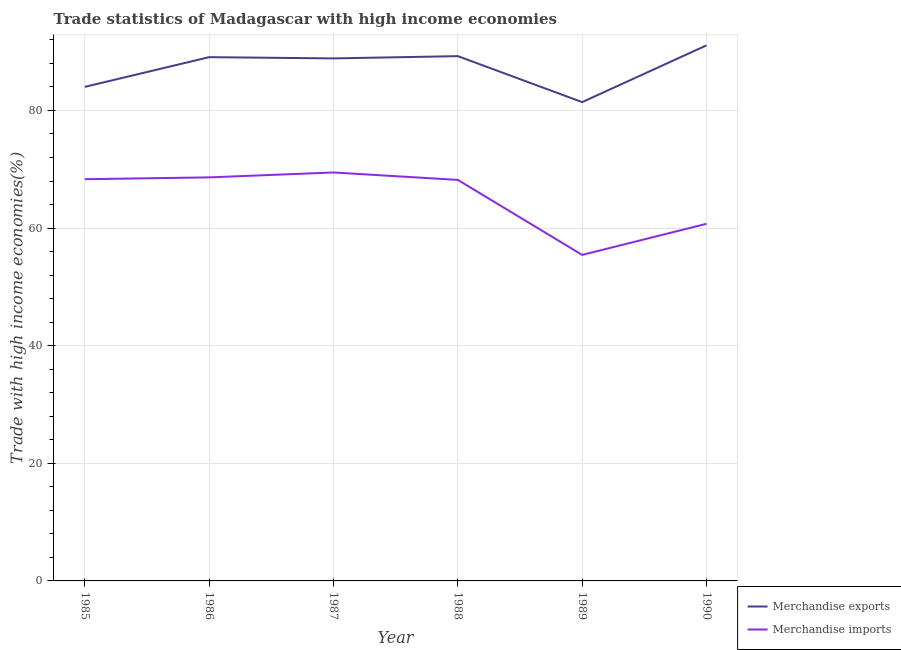Does the line corresponding to merchandise imports intersect with the line corresponding to merchandise exports?
Your answer should be very brief. No. Is the number of lines equal to the number of legend labels?
Your answer should be very brief. Yes. What is the merchandise exports in 1985?
Your response must be concise. 84.01. Across all years, what is the maximum merchandise imports?
Give a very brief answer. 69.45. Across all years, what is the minimum merchandise imports?
Your answer should be very brief. 55.44. In which year was the merchandise imports maximum?
Provide a short and direct response. 1987. In which year was the merchandise exports minimum?
Offer a terse response. 1989. What is the total merchandise imports in the graph?
Make the answer very short. 390.74. What is the difference between the merchandise exports in 1986 and that in 1988?
Offer a terse response. -0.17. What is the difference between the merchandise exports in 1986 and the merchandise imports in 1987?
Give a very brief answer. 19.61. What is the average merchandise exports per year?
Offer a terse response. 87.27. In the year 1989, what is the difference between the merchandise imports and merchandise exports?
Ensure brevity in your answer.  -25.98. In how many years, is the merchandise imports greater than 56 %?
Your answer should be very brief. 5. What is the ratio of the merchandise imports in 1985 to that in 1986?
Your answer should be compact. 1. Is the merchandise exports in 1986 less than that in 1990?
Give a very brief answer. Yes. What is the difference between the highest and the second highest merchandise exports?
Make the answer very short. 1.83. What is the difference between the highest and the lowest merchandise exports?
Keep it short and to the point. 9.65. In how many years, is the merchandise exports greater than the average merchandise exports taken over all years?
Ensure brevity in your answer.  4. Is the sum of the merchandise imports in 1985 and 1986 greater than the maximum merchandise exports across all years?
Offer a very short reply. Yes. Does the merchandise imports monotonically increase over the years?
Your answer should be very brief. No. Is the merchandise exports strictly less than the merchandise imports over the years?
Your answer should be compact. No. How many lines are there?
Ensure brevity in your answer.  2. How are the legend labels stacked?
Make the answer very short. Vertical. What is the title of the graph?
Offer a terse response. Trade statistics of Madagascar with high income economies. Does "RDB nonconcessional" appear as one of the legend labels in the graph?
Your response must be concise. No. What is the label or title of the Y-axis?
Make the answer very short. Trade with high income economies(%). What is the Trade with high income economies(%) of Merchandise exports in 1985?
Your answer should be compact. 84.01. What is the Trade with high income economies(%) in Merchandise imports in 1985?
Offer a very short reply. 68.31. What is the Trade with high income economies(%) in Merchandise exports in 1986?
Ensure brevity in your answer.  89.06. What is the Trade with high income economies(%) of Merchandise imports in 1986?
Your answer should be very brief. 68.62. What is the Trade with high income economies(%) of Merchandise exports in 1987?
Your answer should be very brief. 88.85. What is the Trade with high income economies(%) of Merchandise imports in 1987?
Ensure brevity in your answer.  69.45. What is the Trade with high income economies(%) of Merchandise exports in 1988?
Offer a very short reply. 89.24. What is the Trade with high income economies(%) in Merchandise imports in 1988?
Your answer should be very brief. 68.19. What is the Trade with high income economies(%) of Merchandise exports in 1989?
Offer a terse response. 81.42. What is the Trade with high income economies(%) of Merchandise imports in 1989?
Offer a very short reply. 55.44. What is the Trade with high income economies(%) in Merchandise exports in 1990?
Your answer should be very brief. 91.07. What is the Trade with high income economies(%) in Merchandise imports in 1990?
Provide a succinct answer. 60.73. Across all years, what is the maximum Trade with high income economies(%) in Merchandise exports?
Ensure brevity in your answer.  91.07. Across all years, what is the maximum Trade with high income economies(%) in Merchandise imports?
Give a very brief answer. 69.45. Across all years, what is the minimum Trade with high income economies(%) of Merchandise exports?
Offer a very short reply. 81.42. Across all years, what is the minimum Trade with high income economies(%) of Merchandise imports?
Your answer should be very brief. 55.44. What is the total Trade with high income economies(%) of Merchandise exports in the graph?
Make the answer very short. 523.65. What is the total Trade with high income economies(%) of Merchandise imports in the graph?
Give a very brief answer. 390.74. What is the difference between the Trade with high income economies(%) in Merchandise exports in 1985 and that in 1986?
Make the answer very short. -5.05. What is the difference between the Trade with high income economies(%) in Merchandise imports in 1985 and that in 1986?
Offer a terse response. -0.31. What is the difference between the Trade with high income economies(%) of Merchandise exports in 1985 and that in 1987?
Provide a short and direct response. -4.84. What is the difference between the Trade with high income economies(%) in Merchandise imports in 1985 and that in 1987?
Offer a terse response. -1.14. What is the difference between the Trade with high income economies(%) of Merchandise exports in 1985 and that in 1988?
Offer a very short reply. -5.22. What is the difference between the Trade with high income economies(%) of Merchandise imports in 1985 and that in 1988?
Provide a succinct answer. 0.12. What is the difference between the Trade with high income economies(%) in Merchandise exports in 1985 and that in 1989?
Your answer should be compact. 2.59. What is the difference between the Trade with high income economies(%) of Merchandise imports in 1985 and that in 1989?
Offer a very short reply. 12.87. What is the difference between the Trade with high income economies(%) of Merchandise exports in 1985 and that in 1990?
Make the answer very short. -7.06. What is the difference between the Trade with high income economies(%) of Merchandise imports in 1985 and that in 1990?
Your answer should be very brief. 7.58. What is the difference between the Trade with high income economies(%) of Merchandise exports in 1986 and that in 1987?
Make the answer very short. 0.21. What is the difference between the Trade with high income economies(%) in Merchandise imports in 1986 and that in 1987?
Offer a terse response. -0.83. What is the difference between the Trade with high income economies(%) in Merchandise exports in 1986 and that in 1988?
Provide a short and direct response. -0.17. What is the difference between the Trade with high income economies(%) of Merchandise imports in 1986 and that in 1988?
Your answer should be compact. 0.43. What is the difference between the Trade with high income economies(%) of Merchandise exports in 1986 and that in 1989?
Offer a terse response. 7.64. What is the difference between the Trade with high income economies(%) of Merchandise imports in 1986 and that in 1989?
Offer a terse response. 13.18. What is the difference between the Trade with high income economies(%) of Merchandise exports in 1986 and that in 1990?
Your answer should be compact. -2.01. What is the difference between the Trade with high income economies(%) of Merchandise imports in 1986 and that in 1990?
Provide a short and direct response. 7.89. What is the difference between the Trade with high income economies(%) of Merchandise exports in 1987 and that in 1988?
Your response must be concise. -0.38. What is the difference between the Trade with high income economies(%) in Merchandise imports in 1987 and that in 1988?
Keep it short and to the point. 1.26. What is the difference between the Trade with high income economies(%) in Merchandise exports in 1987 and that in 1989?
Give a very brief answer. 7.43. What is the difference between the Trade with high income economies(%) in Merchandise imports in 1987 and that in 1989?
Ensure brevity in your answer.  14.02. What is the difference between the Trade with high income economies(%) in Merchandise exports in 1987 and that in 1990?
Offer a very short reply. -2.22. What is the difference between the Trade with high income economies(%) of Merchandise imports in 1987 and that in 1990?
Provide a short and direct response. 8.73. What is the difference between the Trade with high income economies(%) in Merchandise exports in 1988 and that in 1989?
Your answer should be very brief. 7.82. What is the difference between the Trade with high income economies(%) of Merchandise imports in 1988 and that in 1989?
Your answer should be very brief. 12.75. What is the difference between the Trade with high income economies(%) in Merchandise exports in 1988 and that in 1990?
Offer a very short reply. -1.83. What is the difference between the Trade with high income economies(%) of Merchandise imports in 1988 and that in 1990?
Your answer should be compact. 7.46. What is the difference between the Trade with high income economies(%) in Merchandise exports in 1989 and that in 1990?
Give a very brief answer. -9.65. What is the difference between the Trade with high income economies(%) in Merchandise imports in 1989 and that in 1990?
Offer a very short reply. -5.29. What is the difference between the Trade with high income economies(%) in Merchandise exports in 1985 and the Trade with high income economies(%) in Merchandise imports in 1986?
Your answer should be compact. 15.39. What is the difference between the Trade with high income economies(%) of Merchandise exports in 1985 and the Trade with high income economies(%) of Merchandise imports in 1987?
Ensure brevity in your answer.  14.56. What is the difference between the Trade with high income economies(%) in Merchandise exports in 1985 and the Trade with high income economies(%) in Merchandise imports in 1988?
Keep it short and to the point. 15.82. What is the difference between the Trade with high income economies(%) in Merchandise exports in 1985 and the Trade with high income economies(%) in Merchandise imports in 1989?
Offer a very short reply. 28.58. What is the difference between the Trade with high income economies(%) in Merchandise exports in 1985 and the Trade with high income economies(%) in Merchandise imports in 1990?
Keep it short and to the point. 23.28. What is the difference between the Trade with high income economies(%) in Merchandise exports in 1986 and the Trade with high income economies(%) in Merchandise imports in 1987?
Your answer should be very brief. 19.61. What is the difference between the Trade with high income economies(%) of Merchandise exports in 1986 and the Trade with high income economies(%) of Merchandise imports in 1988?
Keep it short and to the point. 20.87. What is the difference between the Trade with high income economies(%) in Merchandise exports in 1986 and the Trade with high income economies(%) in Merchandise imports in 1989?
Offer a very short reply. 33.63. What is the difference between the Trade with high income economies(%) in Merchandise exports in 1986 and the Trade with high income economies(%) in Merchandise imports in 1990?
Keep it short and to the point. 28.33. What is the difference between the Trade with high income economies(%) of Merchandise exports in 1987 and the Trade with high income economies(%) of Merchandise imports in 1988?
Your answer should be very brief. 20.66. What is the difference between the Trade with high income economies(%) of Merchandise exports in 1987 and the Trade with high income economies(%) of Merchandise imports in 1989?
Offer a terse response. 33.42. What is the difference between the Trade with high income economies(%) in Merchandise exports in 1987 and the Trade with high income economies(%) in Merchandise imports in 1990?
Ensure brevity in your answer.  28.12. What is the difference between the Trade with high income economies(%) in Merchandise exports in 1988 and the Trade with high income economies(%) in Merchandise imports in 1989?
Ensure brevity in your answer.  33.8. What is the difference between the Trade with high income economies(%) in Merchandise exports in 1988 and the Trade with high income economies(%) in Merchandise imports in 1990?
Your answer should be compact. 28.51. What is the difference between the Trade with high income economies(%) of Merchandise exports in 1989 and the Trade with high income economies(%) of Merchandise imports in 1990?
Your answer should be very brief. 20.69. What is the average Trade with high income economies(%) of Merchandise exports per year?
Offer a terse response. 87.27. What is the average Trade with high income economies(%) of Merchandise imports per year?
Your answer should be compact. 65.12. In the year 1985, what is the difference between the Trade with high income economies(%) in Merchandise exports and Trade with high income economies(%) in Merchandise imports?
Offer a very short reply. 15.7. In the year 1986, what is the difference between the Trade with high income economies(%) of Merchandise exports and Trade with high income economies(%) of Merchandise imports?
Provide a succinct answer. 20.44. In the year 1987, what is the difference between the Trade with high income economies(%) of Merchandise exports and Trade with high income economies(%) of Merchandise imports?
Offer a very short reply. 19.4. In the year 1988, what is the difference between the Trade with high income economies(%) of Merchandise exports and Trade with high income economies(%) of Merchandise imports?
Provide a succinct answer. 21.05. In the year 1989, what is the difference between the Trade with high income economies(%) of Merchandise exports and Trade with high income economies(%) of Merchandise imports?
Offer a very short reply. 25.98. In the year 1990, what is the difference between the Trade with high income economies(%) in Merchandise exports and Trade with high income economies(%) in Merchandise imports?
Make the answer very short. 30.34. What is the ratio of the Trade with high income economies(%) in Merchandise exports in 1985 to that in 1986?
Provide a succinct answer. 0.94. What is the ratio of the Trade with high income economies(%) of Merchandise imports in 1985 to that in 1986?
Make the answer very short. 1. What is the ratio of the Trade with high income economies(%) of Merchandise exports in 1985 to that in 1987?
Ensure brevity in your answer.  0.95. What is the ratio of the Trade with high income economies(%) of Merchandise imports in 1985 to that in 1987?
Keep it short and to the point. 0.98. What is the ratio of the Trade with high income economies(%) in Merchandise exports in 1985 to that in 1988?
Provide a succinct answer. 0.94. What is the ratio of the Trade with high income economies(%) of Merchandise imports in 1985 to that in 1988?
Your answer should be compact. 1. What is the ratio of the Trade with high income economies(%) of Merchandise exports in 1985 to that in 1989?
Your answer should be compact. 1.03. What is the ratio of the Trade with high income economies(%) of Merchandise imports in 1985 to that in 1989?
Give a very brief answer. 1.23. What is the ratio of the Trade with high income economies(%) of Merchandise exports in 1985 to that in 1990?
Keep it short and to the point. 0.92. What is the ratio of the Trade with high income economies(%) of Merchandise imports in 1985 to that in 1990?
Offer a very short reply. 1.12. What is the ratio of the Trade with high income economies(%) of Merchandise exports in 1986 to that in 1987?
Provide a short and direct response. 1. What is the ratio of the Trade with high income economies(%) in Merchandise exports in 1986 to that in 1988?
Provide a short and direct response. 1. What is the ratio of the Trade with high income economies(%) in Merchandise imports in 1986 to that in 1988?
Give a very brief answer. 1.01. What is the ratio of the Trade with high income economies(%) of Merchandise exports in 1986 to that in 1989?
Provide a short and direct response. 1.09. What is the ratio of the Trade with high income economies(%) in Merchandise imports in 1986 to that in 1989?
Your response must be concise. 1.24. What is the ratio of the Trade with high income economies(%) in Merchandise imports in 1986 to that in 1990?
Give a very brief answer. 1.13. What is the ratio of the Trade with high income economies(%) of Merchandise exports in 1987 to that in 1988?
Provide a succinct answer. 1. What is the ratio of the Trade with high income economies(%) in Merchandise imports in 1987 to that in 1988?
Ensure brevity in your answer.  1.02. What is the ratio of the Trade with high income economies(%) of Merchandise exports in 1987 to that in 1989?
Your response must be concise. 1.09. What is the ratio of the Trade with high income economies(%) of Merchandise imports in 1987 to that in 1989?
Your answer should be compact. 1.25. What is the ratio of the Trade with high income economies(%) of Merchandise exports in 1987 to that in 1990?
Give a very brief answer. 0.98. What is the ratio of the Trade with high income economies(%) of Merchandise imports in 1987 to that in 1990?
Ensure brevity in your answer.  1.14. What is the ratio of the Trade with high income economies(%) in Merchandise exports in 1988 to that in 1989?
Give a very brief answer. 1.1. What is the ratio of the Trade with high income economies(%) of Merchandise imports in 1988 to that in 1989?
Provide a succinct answer. 1.23. What is the ratio of the Trade with high income economies(%) of Merchandise exports in 1988 to that in 1990?
Ensure brevity in your answer.  0.98. What is the ratio of the Trade with high income economies(%) in Merchandise imports in 1988 to that in 1990?
Your answer should be compact. 1.12. What is the ratio of the Trade with high income economies(%) in Merchandise exports in 1989 to that in 1990?
Give a very brief answer. 0.89. What is the ratio of the Trade with high income economies(%) of Merchandise imports in 1989 to that in 1990?
Your response must be concise. 0.91. What is the difference between the highest and the second highest Trade with high income economies(%) of Merchandise exports?
Your answer should be compact. 1.83. What is the difference between the highest and the second highest Trade with high income economies(%) in Merchandise imports?
Keep it short and to the point. 0.83. What is the difference between the highest and the lowest Trade with high income economies(%) in Merchandise exports?
Your answer should be very brief. 9.65. What is the difference between the highest and the lowest Trade with high income economies(%) of Merchandise imports?
Your answer should be compact. 14.02. 